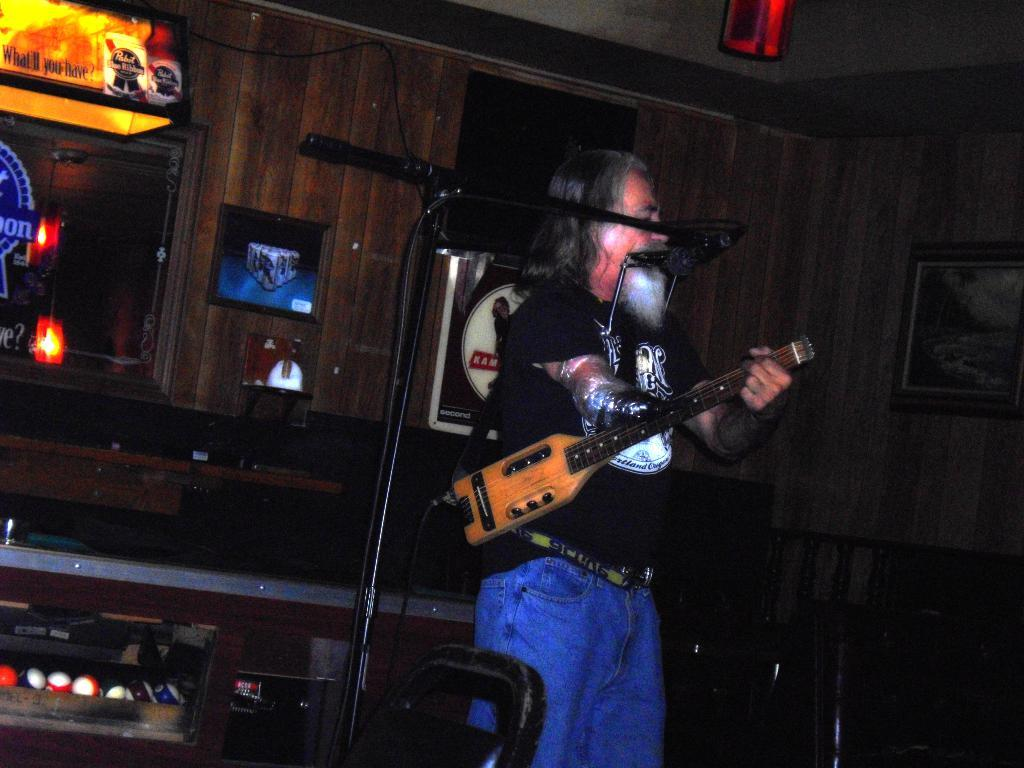<image>
Provide a brief description of the given image. A man plays a stringed instrument next to a pool table illuminated with a Pabst Blue Ribbon light. 